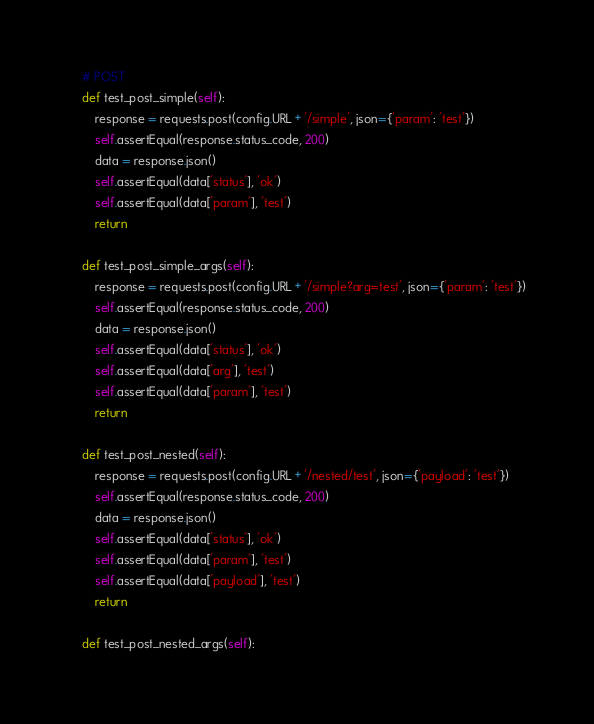<code> <loc_0><loc_0><loc_500><loc_500><_Python_>    # POST
    def test_post_simple(self):
        response = requests.post(config.URL + '/simple', json={'param': 'test'})
        self.assertEqual(response.status_code, 200)
        data = response.json()
        self.assertEqual(data['status'], 'ok')
        self.assertEqual(data['param'], 'test')
        return

    def test_post_simple_args(self):
        response = requests.post(config.URL + '/simple?arg=test', json={'param': 'test'})
        self.assertEqual(response.status_code, 200)
        data = response.json()
        self.assertEqual(data['status'], 'ok')
        self.assertEqual(data['arg'], 'test')
        self.assertEqual(data['param'], 'test')
        return

    def test_post_nested(self):
        response = requests.post(config.URL + '/nested/test', json={'payload': 'test'})
        self.assertEqual(response.status_code, 200)
        data = response.json()
        self.assertEqual(data['status'], 'ok')
        self.assertEqual(data['param'], 'test')
        self.assertEqual(data['payload'], 'test')
        return

    def test_post_nested_args(self):</code> 